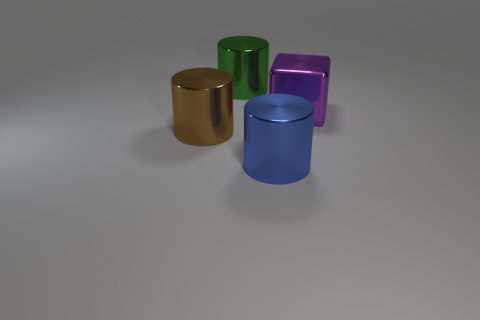Add 2 large purple metal objects. How many objects exist? 6 Subtract all blocks. How many objects are left? 3 Add 3 green things. How many green things are left? 4 Add 3 large purple metal cubes. How many large purple metal cubes exist? 4 Subtract 0 brown spheres. How many objects are left? 4 Subtract all brown shiny objects. Subtract all large blue shiny cylinders. How many objects are left? 2 